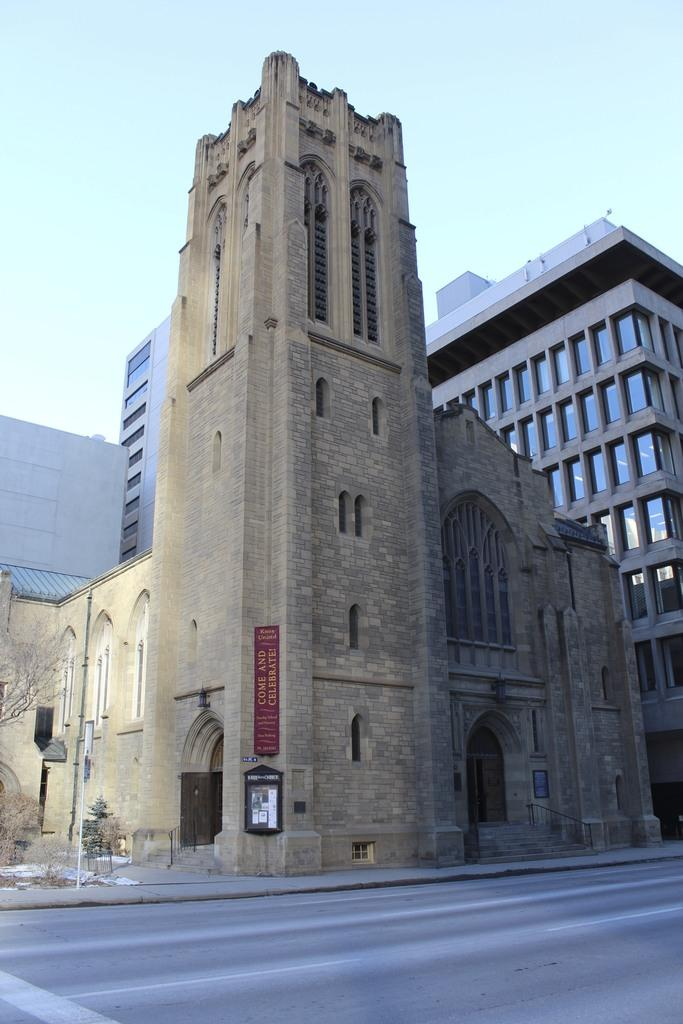What type of pathway is visible in the image? There is a road in the image. What type of natural elements can be seen in the image? There are trees in the image. What type of religious building is present in the image? There is a parish building in the image. What other structures can be seen in the image? There are other buildings in the image. What is visible at the top of the image? The sky is visible at the top of the image and appears clear. What type of quilt is draped over the parish building in the image? There is no quilt present in the image; it features a road, trees, a parish building, other buildings, and a clear sky. How many people are sleeping on the road in the image? There are no people sleeping on the road in the image. 